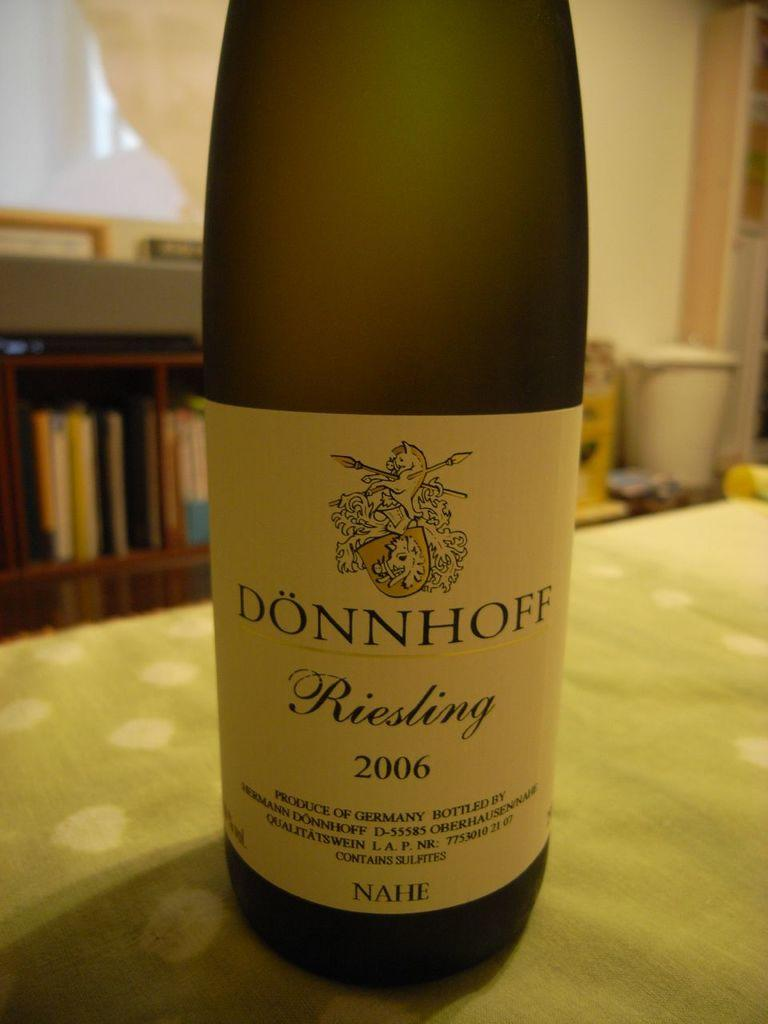<image>
Present a compact description of the photo's key features. a wine bottle with the word Donnhoff on it 